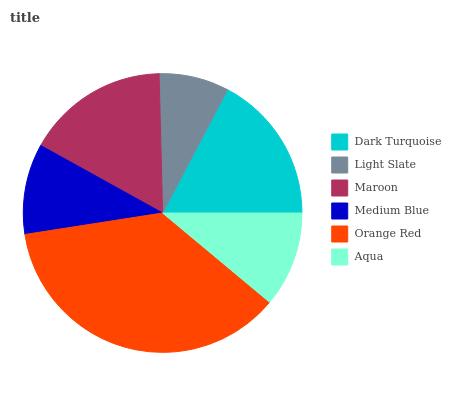Is Light Slate the minimum?
Answer yes or no. Yes. Is Orange Red the maximum?
Answer yes or no. Yes. Is Maroon the minimum?
Answer yes or no. No. Is Maroon the maximum?
Answer yes or no. No. Is Maroon greater than Light Slate?
Answer yes or no. Yes. Is Light Slate less than Maroon?
Answer yes or no. Yes. Is Light Slate greater than Maroon?
Answer yes or no. No. Is Maroon less than Light Slate?
Answer yes or no. No. Is Maroon the high median?
Answer yes or no. Yes. Is Aqua the low median?
Answer yes or no. Yes. Is Light Slate the high median?
Answer yes or no. No. Is Orange Red the low median?
Answer yes or no. No. 